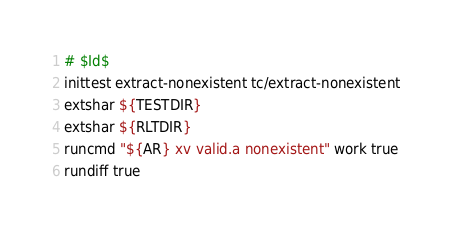<code> <loc_0><loc_0><loc_500><loc_500><_Bash_># $Id$
inittest extract-nonexistent tc/extract-nonexistent
extshar ${TESTDIR}
extshar ${RLTDIR}
runcmd "${AR} xv valid.a nonexistent" work true
rundiff true
</code> 